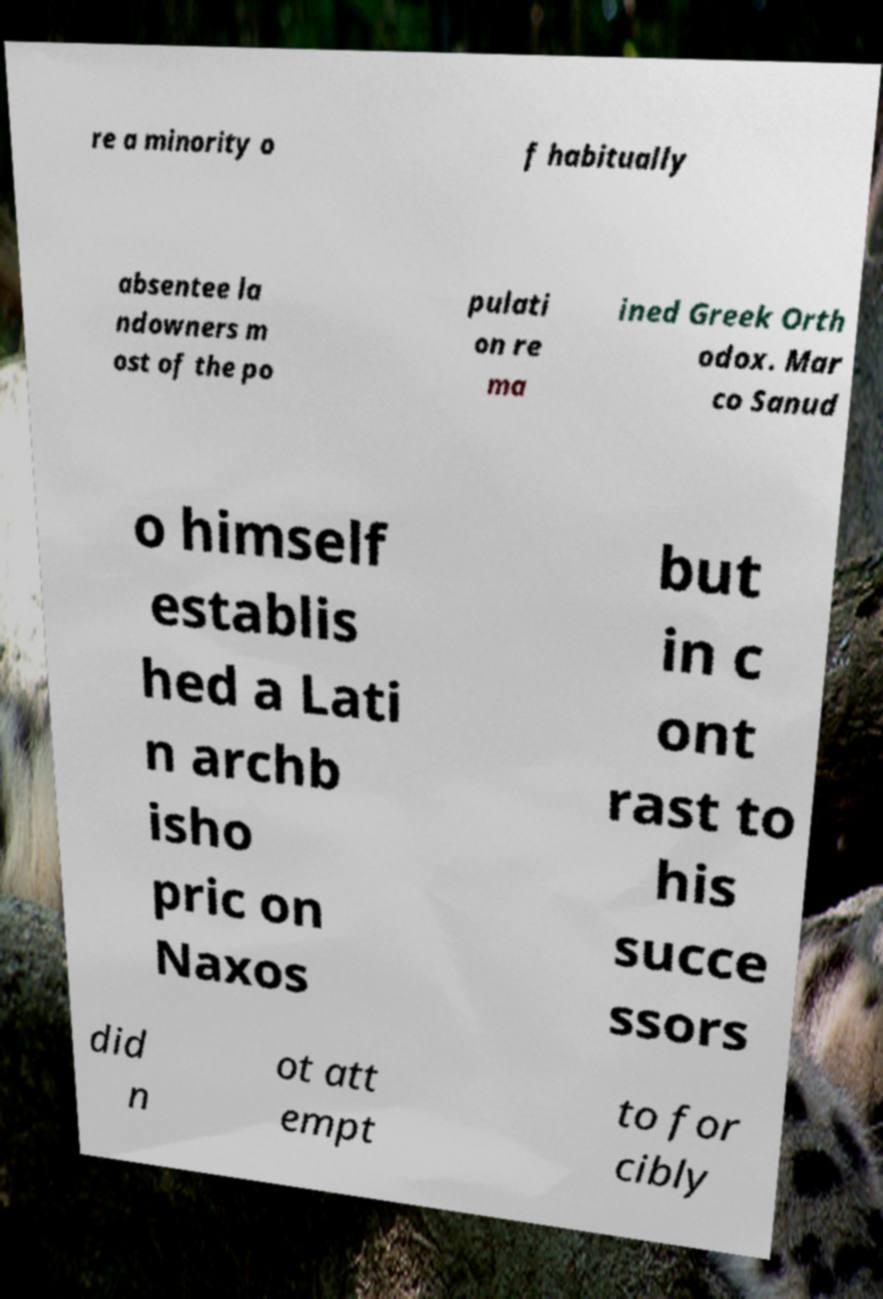I need the written content from this picture converted into text. Can you do that? re a minority o f habitually absentee la ndowners m ost of the po pulati on re ma ined Greek Orth odox. Mar co Sanud o himself establis hed a Lati n archb isho pric on Naxos but in c ont rast to his succe ssors did n ot att empt to for cibly 